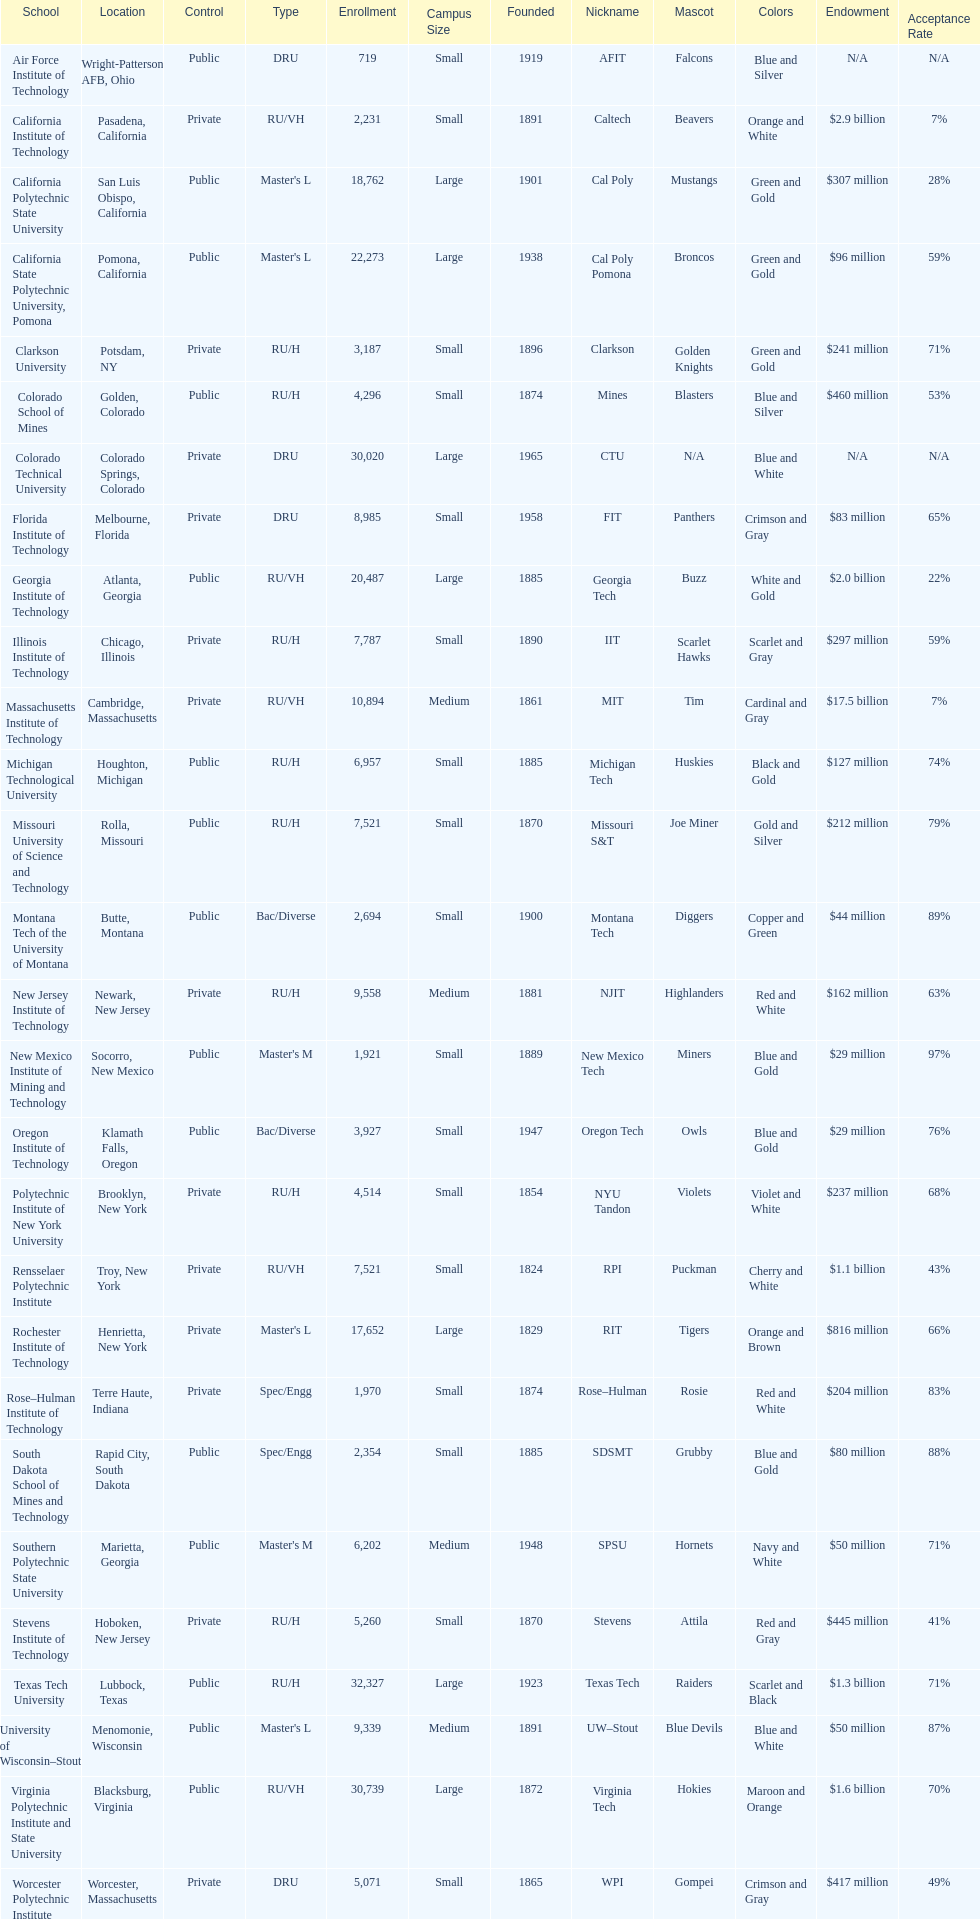What is the total number of schools listed in the table? 28. 